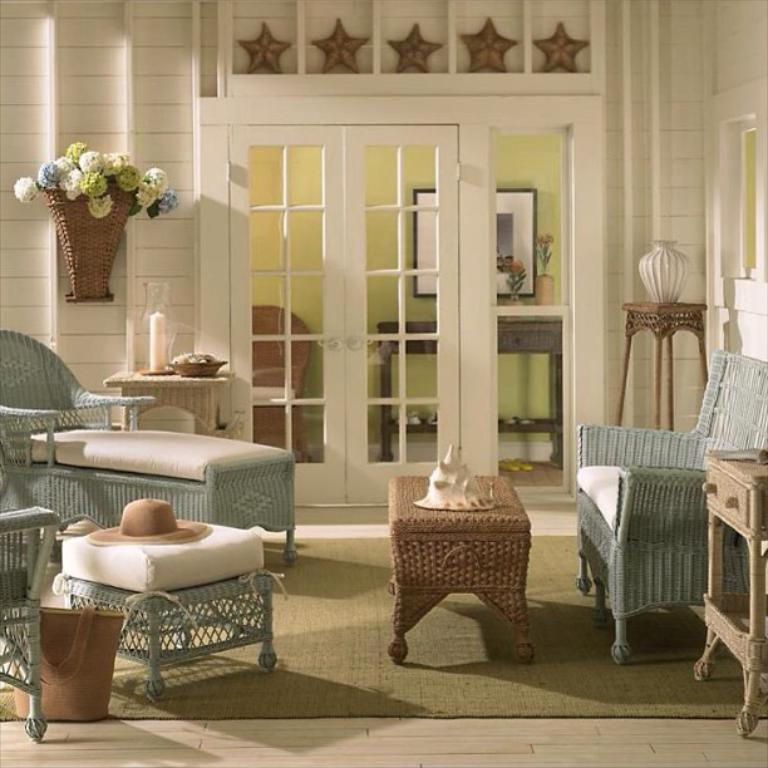What can be found in the room that holds flowers? There is a flower vase in the room. What type of furniture is present in the room? There is a sofa and a table in the room. What is placed on the table? A hat is placed on the table. What decoration can be seen on the wall above the door? There are stars on the wall above the door. How does the smoke from the fireplace affect the room? There is no mention of a fireplace or smoke in the provided facts, so we cannot answer this question. What news is being discussed by the geese in the room? There are no geese present in the room, so we cannot answer this question. 